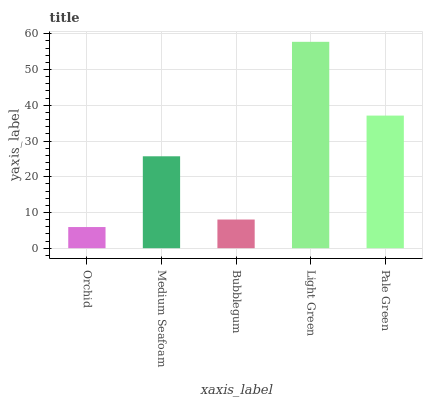Is Medium Seafoam the minimum?
Answer yes or no. No. Is Medium Seafoam the maximum?
Answer yes or no. No. Is Medium Seafoam greater than Orchid?
Answer yes or no. Yes. Is Orchid less than Medium Seafoam?
Answer yes or no. Yes. Is Orchid greater than Medium Seafoam?
Answer yes or no. No. Is Medium Seafoam less than Orchid?
Answer yes or no. No. Is Medium Seafoam the high median?
Answer yes or no. Yes. Is Medium Seafoam the low median?
Answer yes or no. Yes. Is Light Green the high median?
Answer yes or no. No. Is Pale Green the low median?
Answer yes or no. No. 